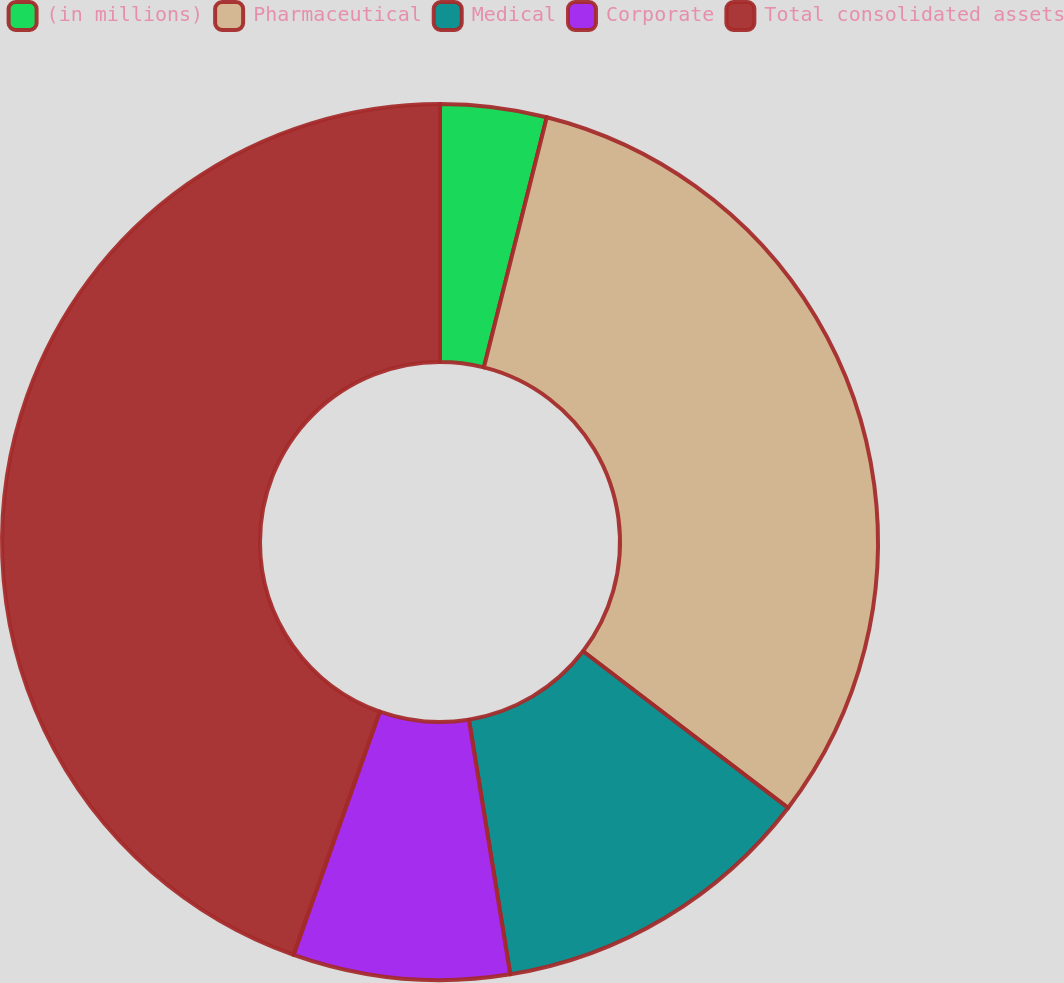Convert chart to OTSL. <chart><loc_0><loc_0><loc_500><loc_500><pie_chart><fcel>(in millions)<fcel>Pharmaceutical<fcel>Medical<fcel>Corporate<fcel>Total consolidated assets<nl><fcel>3.92%<fcel>31.46%<fcel>12.05%<fcel>7.99%<fcel>44.57%<nl></chart> 